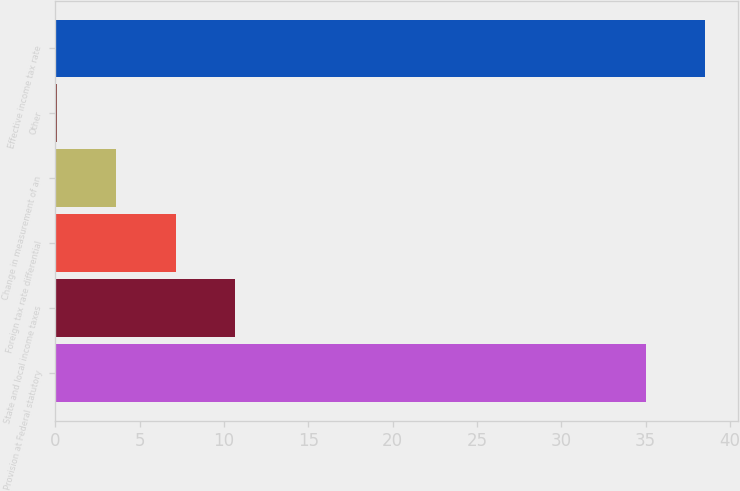Convert chart to OTSL. <chart><loc_0><loc_0><loc_500><loc_500><bar_chart><fcel>Provision at Federal statutory<fcel>State and local income taxes<fcel>Foreign tax rate differential<fcel>Change in measurement of an<fcel>Other<fcel>Effective income tax rate<nl><fcel>35<fcel>10.66<fcel>7.14<fcel>3.62<fcel>0.1<fcel>38.52<nl></chart> 